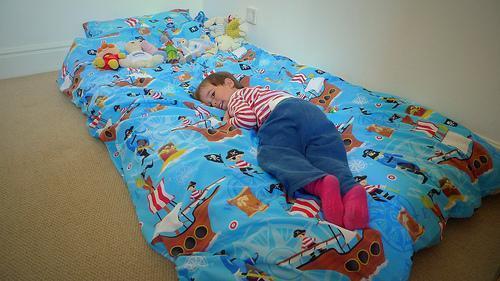How many people can sleep on this bed?
Give a very brief answer. 1. 